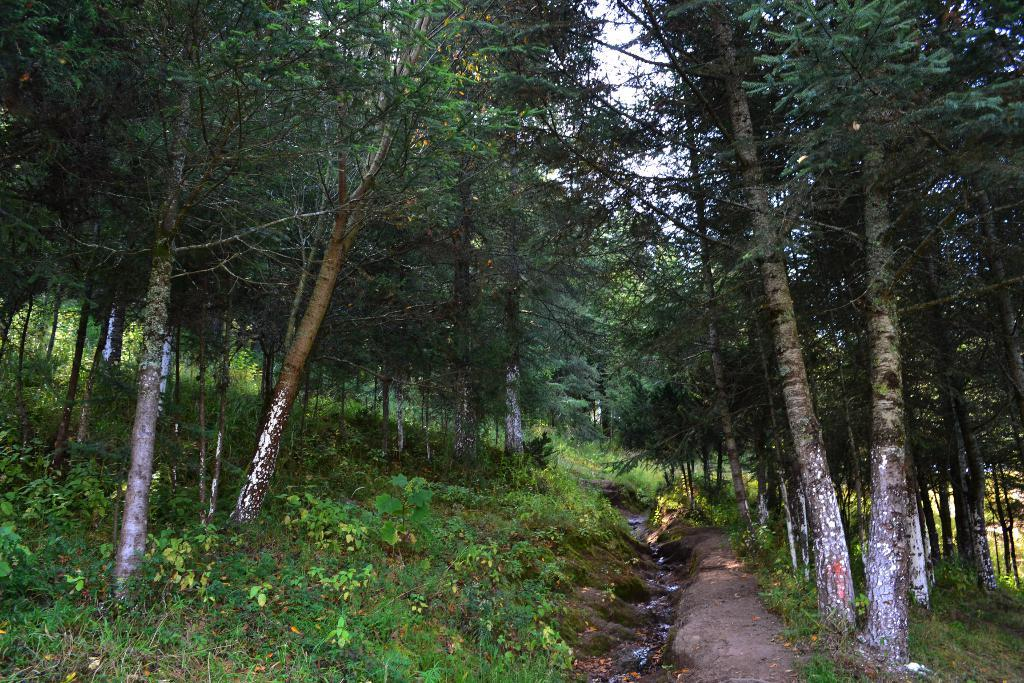What type of vegetation can be seen in the image? There are green plants and trees in the image. What part of the natural environment is visible in the image? The sky is visible in the image. What type of humor can be found in the image? There is no humor present in the image; it features green plants, trees, and the sky. What word is being used to describe the spoon in the image? There is no spoon present in the image, so it cannot be described. 